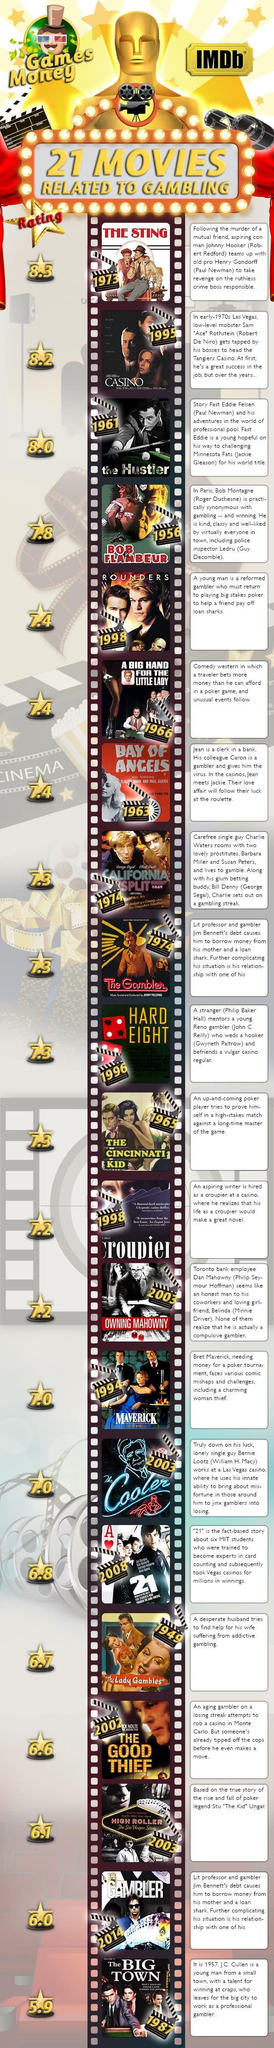Draw attention to some important aspects in this diagram. The Sting, which has the highest rating on IMDB, is considered to be the best gambling movie. Casino, which is the second most highly rated gambling movie according to IMDB, is a captivating film that depicts the dark and dangerous world of organized crime and gambling. The Big Town is the least rated gambling movie according to IMDB. The Cincinnati Kid movie has an IMDb rating of 7.3. The movie "The Sting" was released in the year 1973. 